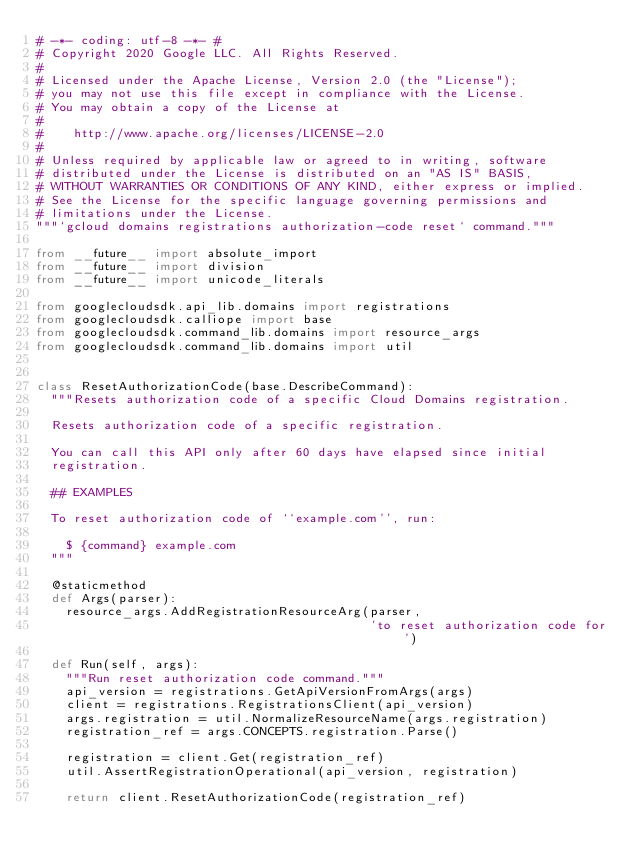Convert code to text. <code><loc_0><loc_0><loc_500><loc_500><_Python_># -*- coding: utf-8 -*- #
# Copyright 2020 Google LLC. All Rights Reserved.
#
# Licensed under the Apache License, Version 2.0 (the "License");
# you may not use this file except in compliance with the License.
# You may obtain a copy of the License at
#
#    http://www.apache.org/licenses/LICENSE-2.0
#
# Unless required by applicable law or agreed to in writing, software
# distributed under the License is distributed on an "AS IS" BASIS,
# WITHOUT WARRANTIES OR CONDITIONS OF ANY KIND, either express or implied.
# See the License for the specific language governing permissions and
# limitations under the License.
"""`gcloud domains registrations authorization-code reset` command."""

from __future__ import absolute_import
from __future__ import division
from __future__ import unicode_literals

from googlecloudsdk.api_lib.domains import registrations
from googlecloudsdk.calliope import base
from googlecloudsdk.command_lib.domains import resource_args
from googlecloudsdk.command_lib.domains import util


class ResetAuthorizationCode(base.DescribeCommand):
  """Resets authorization code of a specific Cloud Domains registration.

  Resets authorization code of a specific registration.

  You can call this API only after 60 days have elapsed since initial
  registration.

  ## EXAMPLES

  To reset authorization code of ``example.com'', run:

    $ {command} example.com
  """

  @staticmethod
  def Args(parser):
    resource_args.AddRegistrationResourceArg(parser,
                                             'to reset authorization code for')

  def Run(self, args):
    """Run reset authorization code command."""
    api_version = registrations.GetApiVersionFromArgs(args)
    client = registrations.RegistrationsClient(api_version)
    args.registration = util.NormalizeResourceName(args.registration)
    registration_ref = args.CONCEPTS.registration.Parse()

    registration = client.Get(registration_ref)
    util.AssertRegistrationOperational(api_version, registration)

    return client.ResetAuthorizationCode(registration_ref)
</code> 